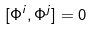Convert formula to latex. <formula><loc_0><loc_0><loc_500><loc_500>\label l { c o m m a t } [ \Phi ^ { i } , \Phi ^ { j } ] = 0</formula> 